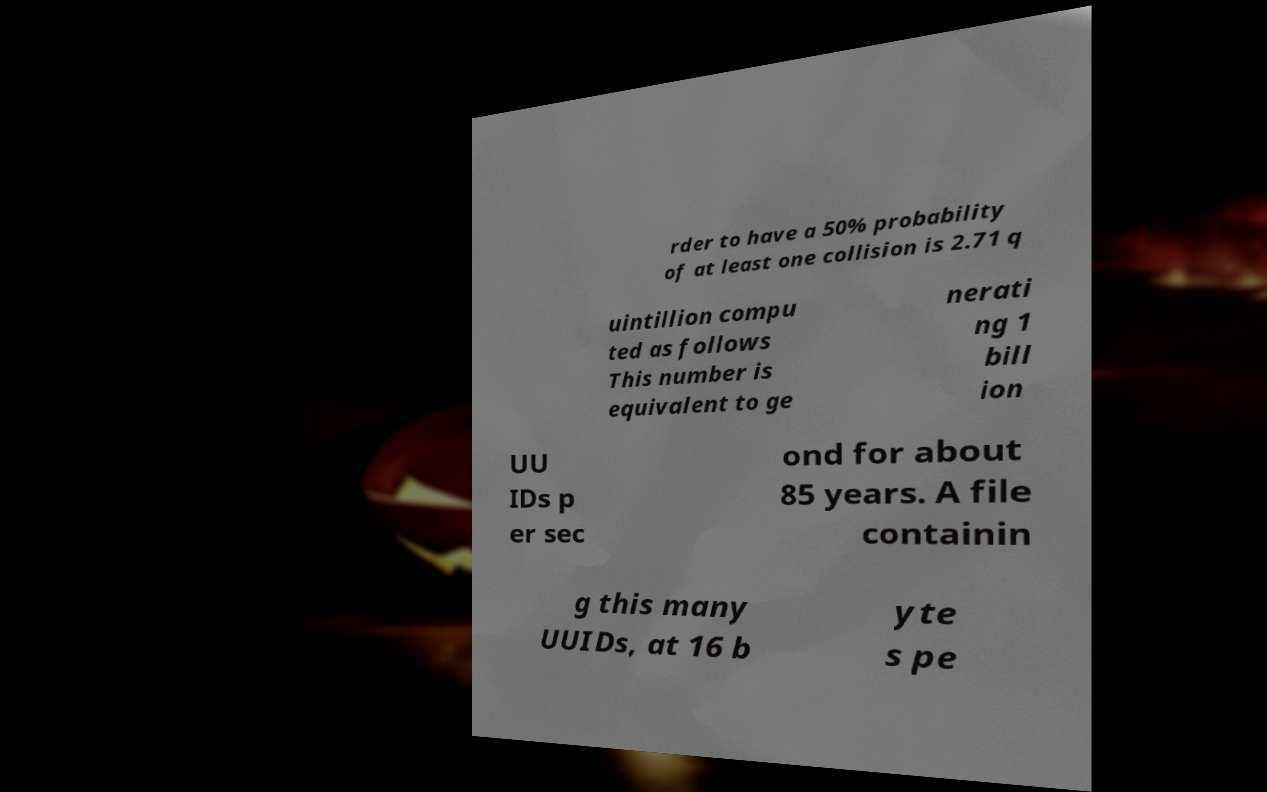Could you assist in decoding the text presented in this image and type it out clearly? rder to have a 50% probability of at least one collision is 2.71 q uintillion compu ted as follows This number is equivalent to ge nerati ng 1 bill ion UU IDs p er sec ond for about 85 years. A file containin g this many UUIDs, at 16 b yte s pe 